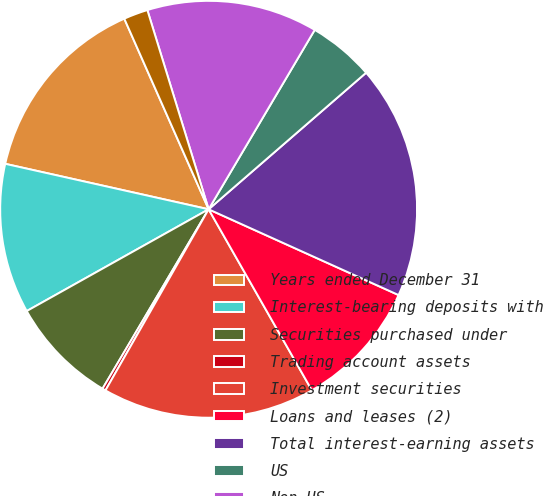Convert chart to OTSL. <chart><loc_0><loc_0><loc_500><loc_500><pie_chart><fcel>Years ended December 31<fcel>Interest-bearing deposits with<fcel>Securities purchased under<fcel>Trading account assets<fcel>Investment securities<fcel>Loans and leases (2)<fcel>Total interest-earning assets<fcel>US<fcel>Non-US<fcel>Securities sold under<nl><fcel>14.87%<fcel>11.62%<fcel>8.38%<fcel>0.26%<fcel>16.49%<fcel>10.0%<fcel>18.12%<fcel>5.13%<fcel>13.25%<fcel>1.88%<nl></chart> 